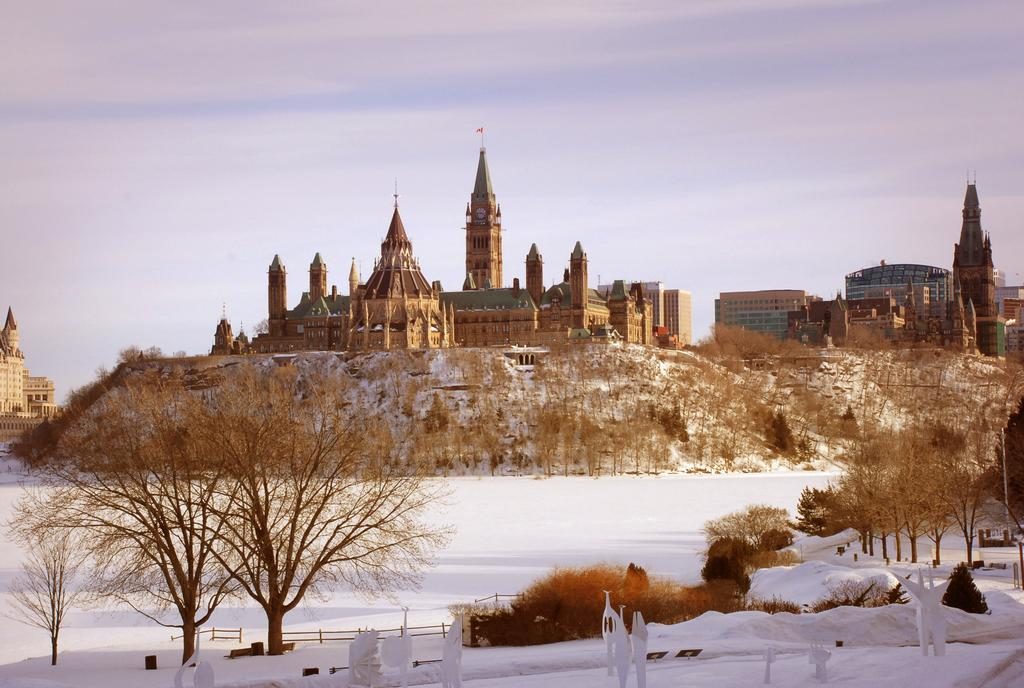What is the main subject in the center of the image? There is a castle in the center of the image. What is the ground covered with at the bottom of the image? There is snow at the bottom of the image. Are there any natural elements visible in the image? Yes, there are trees in the image. Can you see a goose flying through the rainstorm in the image? There is no goose or rainstorm present in the image. What type of apparatus is being used to clear the snow in the image? There is no apparatus visible in the image for clearing snow; the snow is simply present on the ground. 